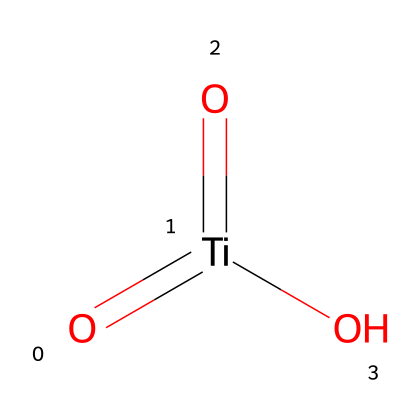What is the oxidation state of titanium in this compound? In the chemical structure O=[Ti](=O)O, titanium (Ti) is bonded to two oxygen atoms with double bonds and one oxygen atom with a single bond. Each double-bonded oxygen contributes -2 to the total oxidation state, and the single-bonded oxygen contributes -1. Therefore, to balance the charges to zero in a neutral compound, the oxidation state of titanium must be +4.
Answer: +4 How many oxygen atoms are in this chemical structure? The SMILES representation shows three oxygen atoms: two are connected by double bonds, and one is connected by a single bond to titanium. Counting these gives a total of three oxygen atoms.
Answer: 3 What type of bonds are present between titanium and oxygen in this structure? The structure contains two double bonds and one single bond between titanium and the three oxygen atoms. This can be seen from the SMILES notation where the consciousness of '=' indicates double bonds leading to the presence of two high-energy bonds and one lower-energy single bond.
Answer: double and single What is the coordination of titanium in this compound? Titanium is coordinated to three oxygen atoms formed through two double bonds and one single bond. This arrangement indicates that titanium forms a total coordination of three in this specific arrangement, leading to a trigonal planar geometry potentially around titanium due to this three-fold connectivity.
Answer: trigonal planar How does this structure contribute to photocatalytic activity? The presence of multiple oxygen atoms bonded to titanium creates a suitable environment for the generation and transfer of charge carriers upon photoexcitation. The specific valency and bond types allow effective light absorption and electron-hole pair separation, which are essential for photocatalytic reactions, particularly in self-cleaning applications.
Answer: light absorption 